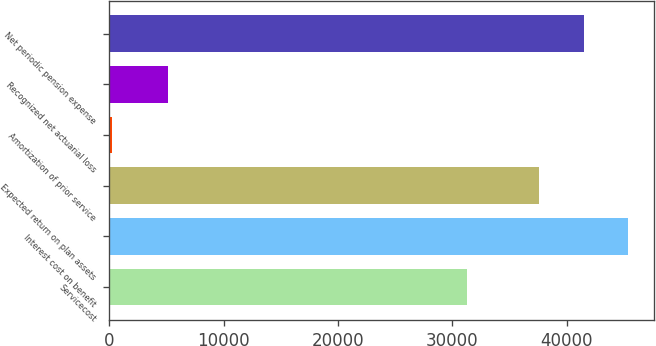<chart> <loc_0><loc_0><loc_500><loc_500><bar_chart><fcel>Servicecost<fcel>Interest cost on benefit<fcel>Expected return on plan assets<fcel>Amortization of prior service<fcel>Recognized net actuarial loss<fcel>Net periodic pension expense<nl><fcel>31240<fcel>45338.2<fcel>37579<fcel>245<fcel>5190<fcel>41458.6<nl></chart> 